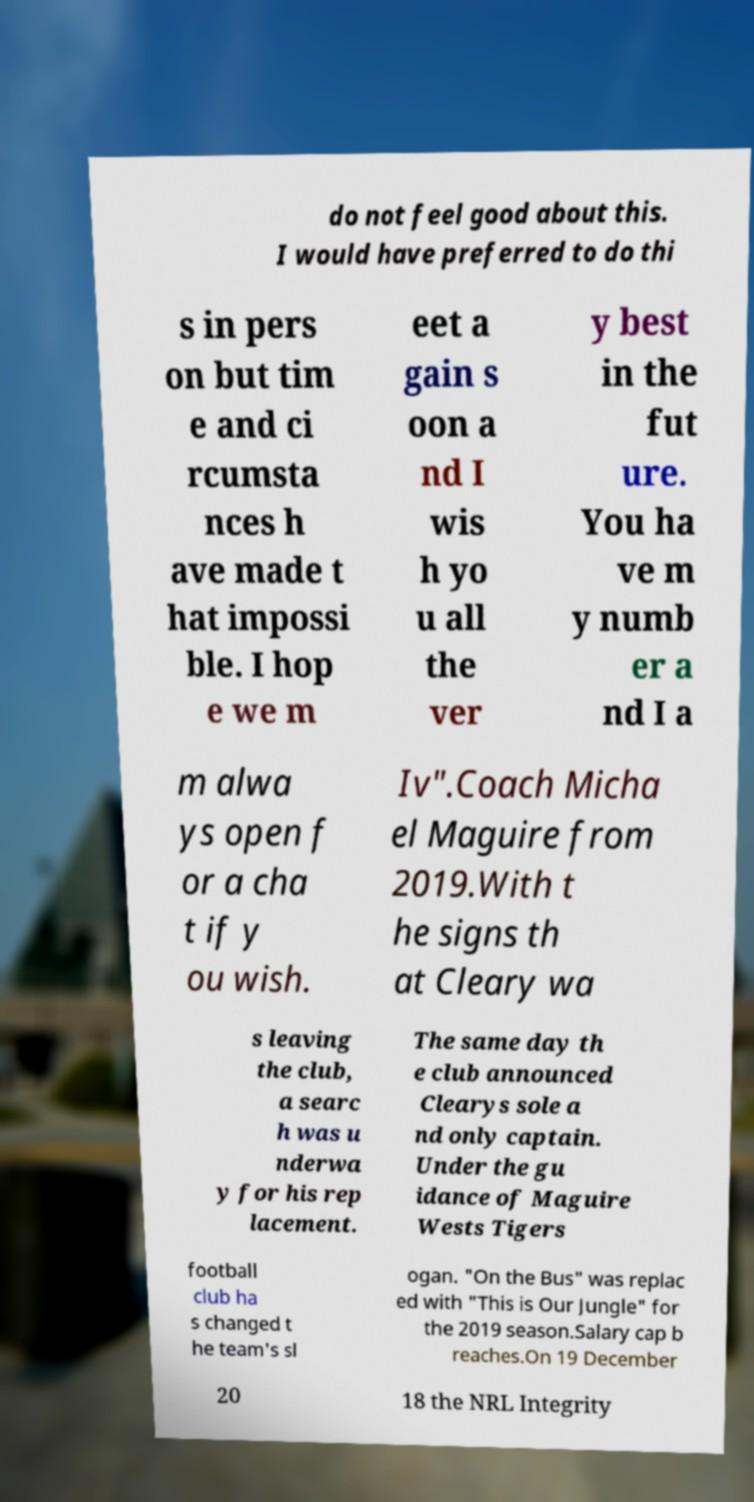I need the written content from this picture converted into text. Can you do that? do not feel good about this. I would have preferred to do thi s in pers on but tim e and ci rcumsta nces h ave made t hat impossi ble. I hop e we m eet a gain s oon a nd I wis h yo u all the ver y best in the fut ure. You ha ve m y numb er a nd I a m alwa ys open f or a cha t if y ou wish. Iv".Coach Micha el Maguire from 2019.With t he signs th at Cleary wa s leaving the club, a searc h was u nderwa y for his rep lacement. The same day th e club announced Clearys sole a nd only captain. Under the gu idance of Maguire Wests Tigers football club ha s changed t he team's sl ogan. "On the Bus" was replac ed with "This is Our Jungle" for the 2019 season.Salary cap b reaches.On 19 December 20 18 the NRL Integrity 